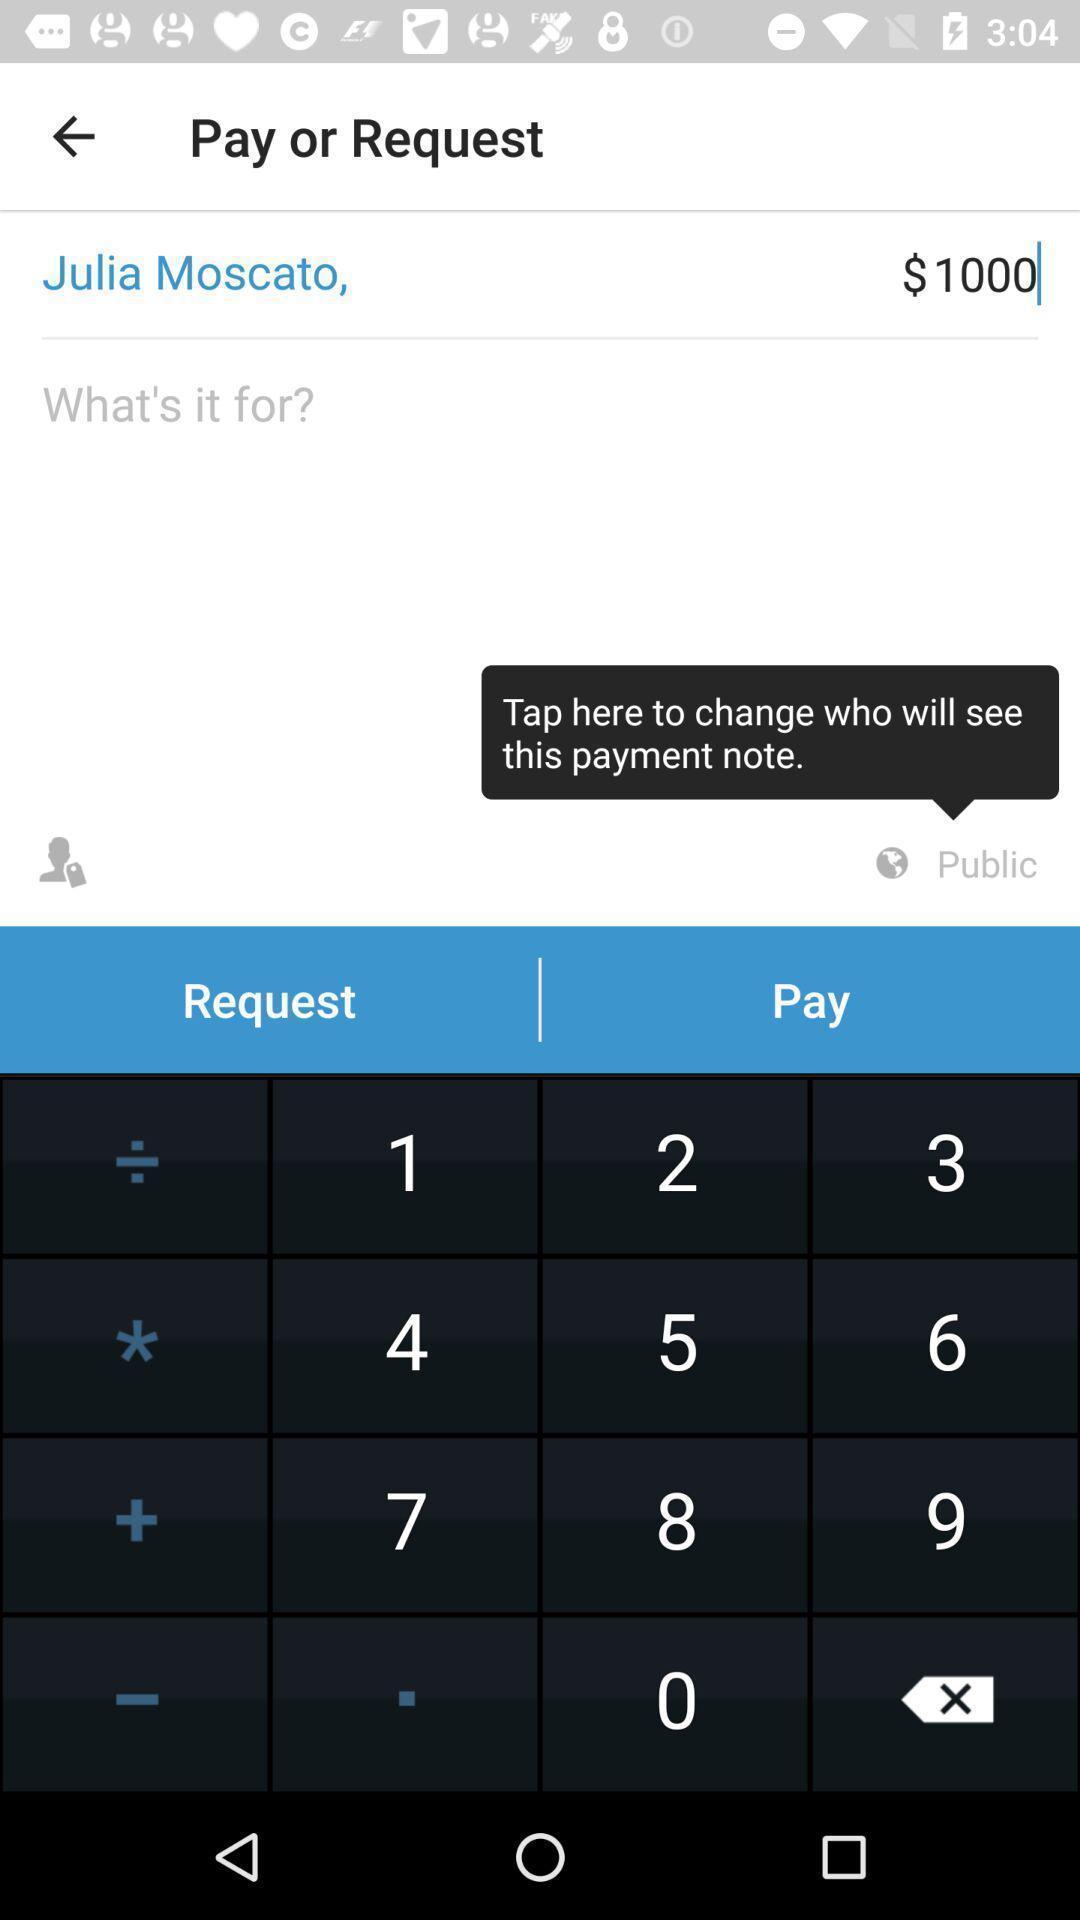Explain the elements present in this screenshot. Screen asking to pay/request on a mobile financing app. 